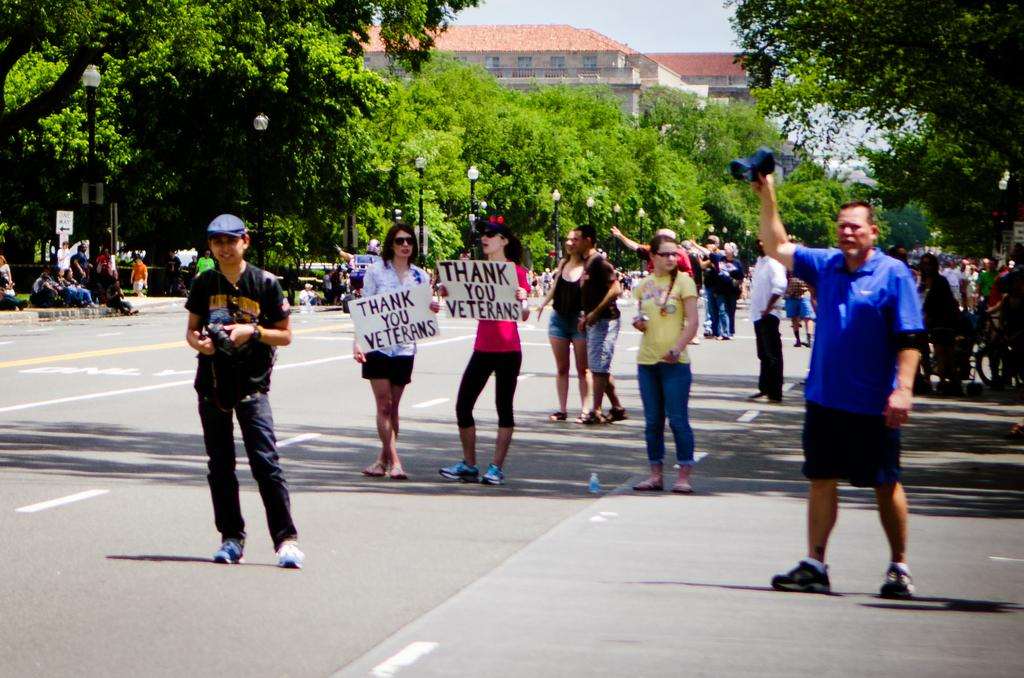What are the people in the image doing with their hands? The people in the image are holding placards. What is the activity of the people in the image? The people are walking on the road. What can be seen in the background of the image? There are light poles, trees, at least one building, and the sky visible in the background of the image. What type of toys can be seen in the hands of the people in the image? There are no toys present in the image; the people are holding placards. Can you spot a rabbit hopping in the background of the image? There is no rabbit present in the image; the background features light poles, trees, a building, and the sky. 